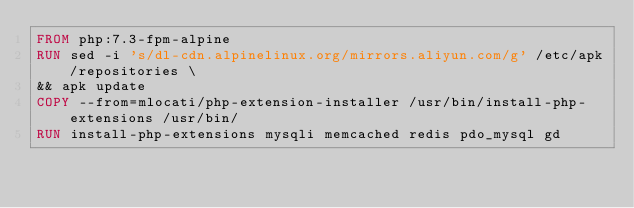Convert code to text. <code><loc_0><loc_0><loc_500><loc_500><_Dockerfile_>FROM php:7.3-fpm-alpine
RUN sed -i 's/dl-cdn.alpinelinux.org/mirrors.aliyun.com/g' /etc/apk/repositories \
&& apk update
COPY --from=mlocati/php-extension-installer /usr/bin/install-php-extensions /usr/bin/
RUN install-php-extensions mysqli memcached redis pdo_mysql gd</code> 